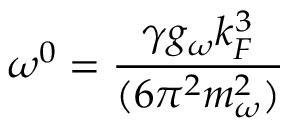<formula> <loc_0><loc_0><loc_500><loc_500>\omega ^ { 0 } = \frac { \gamma g _ { \omega } k _ { F } ^ { 3 } } { ( 6 \pi ^ { 2 } m _ { \omega } ^ { 2 } ) }</formula> 